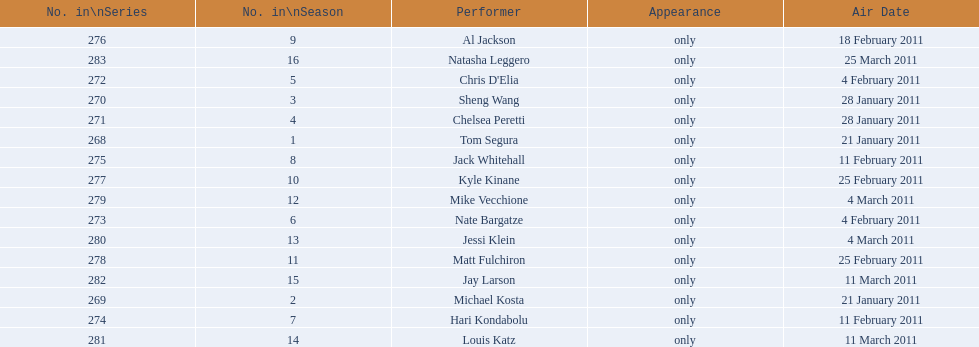Over how many weeks did the 15th season of comedy central presents extend? 9. 